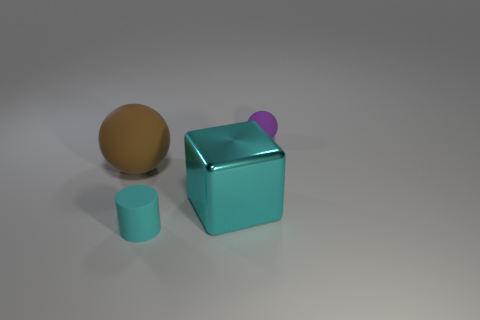Add 2 brown matte things. How many objects exist? 6 Add 4 green rubber cylinders. How many green rubber cylinders exist? 4 Subtract 0 blue blocks. How many objects are left? 4 Subtract all large brown rubber cylinders. Subtract all cyan objects. How many objects are left? 2 Add 3 large brown balls. How many large brown balls are left? 4 